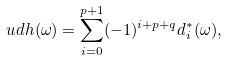<formula> <loc_0><loc_0><loc_500><loc_500>\ u d h ( \omega ) = \sum _ { i = 0 } ^ { p + 1 } ( - 1 ) ^ { i + p + q } d _ { i } ^ { * } ( \omega ) ,</formula> 